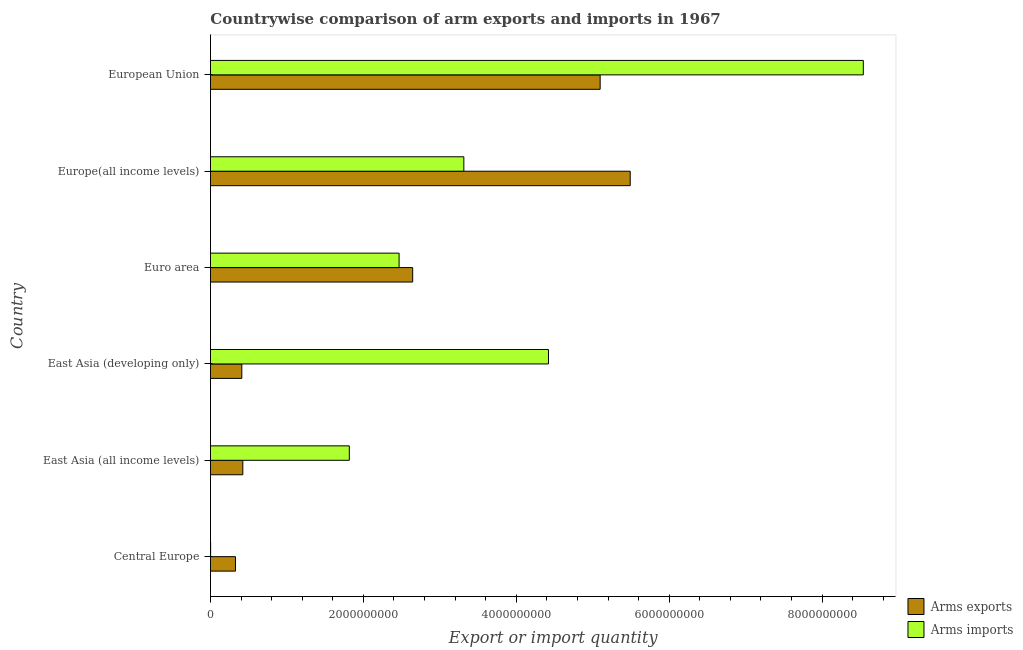How many different coloured bars are there?
Ensure brevity in your answer.  2. Are the number of bars per tick equal to the number of legend labels?
Make the answer very short. Yes. Are the number of bars on each tick of the Y-axis equal?
Keep it short and to the point. Yes. How many bars are there on the 5th tick from the top?
Keep it short and to the point. 2. How many bars are there on the 4th tick from the bottom?
Give a very brief answer. 2. What is the label of the 5th group of bars from the top?
Offer a very short reply. East Asia (all income levels). In how many cases, is the number of bars for a given country not equal to the number of legend labels?
Your response must be concise. 0. What is the arms imports in Europe(all income levels)?
Your response must be concise. 3.31e+09. Across all countries, what is the maximum arms imports?
Provide a short and direct response. 8.54e+09. Across all countries, what is the minimum arms imports?
Give a very brief answer. 2.00e+06. In which country was the arms imports maximum?
Your answer should be very brief. European Union. In which country was the arms imports minimum?
Your answer should be very brief. Central Europe. What is the total arms imports in the graph?
Make the answer very short. 2.06e+1. What is the difference between the arms imports in East Asia (all income levels) and that in Euro area?
Your response must be concise. -6.51e+08. What is the difference between the arms exports in Central Europe and the arms imports in East Asia (developing only)?
Provide a short and direct response. -4.09e+09. What is the average arms exports per country?
Ensure brevity in your answer.  2.40e+09. What is the difference between the arms exports and arms imports in European Union?
Keep it short and to the point. -3.44e+09. In how many countries, is the arms exports greater than 2400000000 ?
Provide a short and direct response. 3. What is the ratio of the arms exports in Euro area to that in European Union?
Ensure brevity in your answer.  0.52. Is the difference between the arms exports in East Asia (all income levels) and European Union greater than the difference between the arms imports in East Asia (all income levels) and European Union?
Offer a terse response. Yes. What is the difference between the highest and the second highest arms imports?
Ensure brevity in your answer.  4.12e+09. What is the difference between the highest and the lowest arms imports?
Your response must be concise. 8.54e+09. What does the 2nd bar from the top in Central Europe represents?
Your response must be concise. Arms exports. What does the 1st bar from the bottom in East Asia (all income levels) represents?
Your answer should be compact. Arms exports. How many bars are there?
Give a very brief answer. 12. What is the difference between two consecutive major ticks on the X-axis?
Offer a very short reply. 2.00e+09. Are the values on the major ticks of X-axis written in scientific E-notation?
Offer a terse response. No. Where does the legend appear in the graph?
Keep it short and to the point. Bottom right. What is the title of the graph?
Your response must be concise. Countrywise comparison of arm exports and imports in 1967. Does "Nonresident" appear as one of the legend labels in the graph?
Offer a terse response. No. What is the label or title of the X-axis?
Provide a short and direct response. Export or import quantity. What is the label or title of the Y-axis?
Offer a very short reply. Country. What is the Export or import quantity of Arms exports in Central Europe?
Your response must be concise. 3.27e+08. What is the Export or import quantity of Arms exports in East Asia (all income levels)?
Your answer should be very brief. 4.23e+08. What is the Export or import quantity of Arms imports in East Asia (all income levels)?
Your response must be concise. 1.82e+09. What is the Export or import quantity in Arms exports in East Asia (developing only)?
Provide a short and direct response. 4.10e+08. What is the Export or import quantity of Arms imports in East Asia (developing only)?
Provide a succinct answer. 4.42e+09. What is the Export or import quantity of Arms exports in Euro area?
Your answer should be compact. 2.64e+09. What is the Export or import quantity in Arms imports in Euro area?
Your answer should be very brief. 2.47e+09. What is the Export or import quantity in Arms exports in Europe(all income levels)?
Give a very brief answer. 5.49e+09. What is the Export or import quantity in Arms imports in Europe(all income levels)?
Make the answer very short. 3.31e+09. What is the Export or import quantity of Arms exports in European Union?
Keep it short and to the point. 5.10e+09. What is the Export or import quantity in Arms imports in European Union?
Give a very brief answer. 8.54e+09. Across all countries, what is the maximum Export or import quantity in Arms exports?
Your answer should be compact. 5.49e+09. Across all countries, what is the maximum Export or import quantity of Arms imports?
Ensure brevity in your answer.  8.54e+09. Across all countries, what is the minimum Export or import quantity of Arms exports?
Provide a short and direct response. 3.27e+08. Across all countries, what is the minimum Export or import quantity in Arms imports?
Provide a short and direct response. 2.00e+06. What is the total Export or import quantity in Arms exports in the graph?
Make the answer very short. 1.44e+1. What is the total Export or import quantity in Arms imports in the graph?
Your response must be concise. 2.06e+1. What is the difference between the Export or import quantity of Arms exports in Central Europe and that in East Asia (all income levels)?
Provide a succinct answer. -9.60e+07. What is the difference between the Export or import quantity of Arms imports in Central Europe and that in East Asia (all income levels)?
Provide a succinct answer. -1.81e+09. What is the difference between the Export or import quantity in Arms exports in Central Europe and that in East Asia (developing only)?
Make the answer very short. -8.30e+07. What is the difference between the Export or import quantity of Arms imports in Central Europe and that in East Asia (developing only)?
Your answer should be very brief. -4.42e+09. What is the difference between the Export or import quantity in Arms exports in Central Europe and that in Euro area?
Your answer should be compact. -2.32e+09. What is the difference between the Export or import quantity of Arms imports in Central Europe and that in Euro area?
Provide a succinct answer. -2.46e+09. What is the difference between the Export or import quantity of Arms exports in Central Europe and that in Europe(all income levels)?
Offer a very short reply. -5.16e+09. What is the difference between the Export or import quantity in Arms imports in Central Europe and that in Europe(all income levels)?
Offer a terse response. -3.31e+09. What is the difference between the Export or import quantity in Arms exports in Central Europe and that in European Union?
Your response must be concise. -4.77e+09. What is the difference between the Export or import quantity in Arms imports in Central Europe and that in European Union?
Make the answer very short. -8.54e+09. What is the difference between the Export or import quantity of Arms exports in East Asia (all income levels) and that in East Asia (developing only)?
Provide a short and direct response. 1.30e+07. What is the difference between the Export or import quantity of Arms imports in East Asia (all income levels) and that in East Asia (developing only)?
Provide a succinct answer. -2.60e+09. What is the difference between the Export or import quantity of Arms exports in East Asia (all income levels) and that in Euro area?
Your answer should be compact. -2.22e+09. What is the difference between the Export or import quantity of Arms imports in East Asia (all income levels) and that in Euro area?
Your answer should be very brief. -6.51e+08. What is the difference between the Export or import quantity in Arms exports in East Asia (all income levels) and that in Europe(all income levels)?
Offer a very short reply. -5.07e+09. What is the difference between the Export or import quantity of Arms imports in East Asia (all income levels) and that in Europe(all income levels)?
Your response must be concise. -1.50e+09. What is the difference between the Export or import quantity in Arms exports in East Asia (all income levels) and that in European Union?
Your response must be concise. -4.67e+09. What is the difference between the Export or import quantity in Arms imports in East Asia (all income levels) and that in European Union?
Offer a very short reply. -6.72e+09. What is the difference between the Export or import quantity of Arms exports in East Asia (developing only) and that in Euro area?
Your answer should be compact. -2.24e+09. What is the difference between the Export or import quantity of Arms imports in East Asia (developing only) and that in Euro area?
Your response must be concise. 1.95e+09. What is the difference between the Export or import quantity of Arms exports in East Asia (developing only) and that in Europe(all income levels)?
Your answer should be compact. -5.08e+09. What is the difference between the Export or import quantity of Arms imports in East Asia (developing only) and that in Europe(all income levels)?
Your answer should be very brief. 1.11e+09. What is the difference between the Export or import quantity of Arms exports in East Asia (developing only) and that in European Union?
Keep it short and to the point. -4.69e+09. What is the difference between the Export or import quantity in Arms imports in East Asia (developing only) and that in European Union?
Keep it short and to the point. -4.12e+09. What is the difference between the Export or import quantity of Arms exports in Euro area and that in Europe(all income levels)?
Ensure brevity in your answer.  -2.84e+09. What is the difference between the Export or import quantity in Arms imports in Euro area and that in Europe(all income levels)?
Give a very brief answer. -8.47e+08. What is the difference between the Export or import quantity of Arms exports in Euro area and that in European Union?
Give a very brief answer. -2.45e+09. What is the difference between the Export or import quantity in Arms imports in Euro area and that in European Union?
Provide a succinct answer. -6.07e+09. What is the difference between the Export or import quantity in Arms exports in Europe(all income levels) and that in European Union?
Your answer should be compact. 3.93e+08. What is the difference between the Export or import quantity of Arms imports in Europe(all income levels) and that in European Union?
Your response must be concise. -5.22e+09. What is the difference between the Export or import quantity in Arms exports in Central Europe and the Export or import quantity in Arms imports in East Asia (all income levels)?
Your answer should be very brief. -1.49e+09. What is the difference between the Export or import quantity of Arms exports in Central Europe and the Export or import quantity of Arms imports in East Asia (developing only)?
Give a very brief answer. -4.09e+09. What is the difference between the Export or import quantity in Arms exports in Central Europe and the Export or import quantity in Arms imports in Euro area?
Offer a very short reply. -2.14e+09. What is the difference between the Export or import quantity of Arms exports in Central Europe and the Export or import quantity of Arms imports in Europe(all income levels)?
Your answer should be very brief. -2.99e+09. What is the difference between the Export or import quantity in Arms exports in Central Europe and the Export or import quantity in Arms imports in European Union?
Ensure brevity in your answer.  -8.21e+09. What is the difference between the Export or import quantity of Arms exports in East Asia (all income levels) and the Export or import quantity of Arms imports in East Asia (developing only)?
Provide a short and direct response. -4.00e+09. What is the difference between the Export or import quantity in Arms exports in East Asia (all income levels) and the Export or import quantity in Arms imports in Euro area?
Your answer should be compact. -2.04e+09. What is the difference between the Export or import quantity of Arms exports in East Asia (all income levels) and the Export or import quantity of Arms imports in Europe(all income levels)?
Provide a short and direct response. -2.89e+09. What is the difference between the Export or import quantity of Arms exports in East Asia (all income levels) and the Export or import quantity of Arms imports in European Union?
Keep it short and to the point. -8.12e+09. What is the difference between the Export or import quantity of Arms exports in East Asia (developing only) and the Export or import quantity of Arms imports in Euro area?
Offer a terse response. -2.06e+09. What is the difference between the Export or import quantity in Arms exports in East Asia (developing only) and the Export or import quantity in Arms imports in Europe(all income levels)?
Your answer should be compact. -2.90e+09. What is the difference between the Export or import quantity of Arms exports in East Asia (developing only) and the Export or import quantity of Arms imports in European Union?
Offer a very short reply. -8.13e+09. What is the difference between the Export or import quantity in Arms exports in Euro area and the Export or import quantity in Arms imports in Europe(all income levels)?
Your response must be concise. -6.69e+08. What is the difference between the Export or import quantity in Arms exports in Euro area and the Export or import quantity in Arms imports in European Union?
Provide a short and direct response. -5.89e+09. What is the difference between the Export or import quantity in Arms exports in Europe(all income levels) and the Export or import quantity in Arms imports in European Union?
Your response must be concise. -3.05e+09. What is the average Export or import quantity of Arms exports per country?
Give a very brief answer. 2.40e+09. What is the average Export or import quantity of Arms imports per country?
Ensure brevity in your answer.  3.43e+09. What is the difference between the Export or import quantity in Arms exports and Export or import quantity in Arms imports in Central Europe?
Offer a terse response. 3.25e+08. What is the difference between the Export or import quantity of Arms exports and Export or import quantity of Arms imports in East Asia (all income levels)?
Offer a very short reply. -1.39e+09. What is the difference between the Export or import quantity in Arms exports and Export or import quantity in Arms imports in East Asia (developing only)?
Your answer should be compact. -4.01e+09. What is the difference between the Export or import quantity in Arms exports and Export or import quantity in Arms imports in Euro area?
Ensure brevity in your answer.  1.78e+08. What is the difference between the Export or import quantity of Arms exports and Export or import quantity of Arms imports in Europe(all income levels)?
Offer a terse response. 2.18e+09. What is the difference between the Export or import quantity of Arms exports and Export or import quantity of Arms imports in European Union?
Provide a short and direct response. -3.44e+09. What is the ratio of the Export or import quantity of Arms exports in Central Europe to that in East Asia (all income levels)?
Ensure brevity in your answer.  0.77. What is the ratio of the Export or import quantity in Arms imports in Central Europe to that in East Asia (all income levels)?
Offer a terse response. 0. What is the ratio of the Export or import quantity of Arms exports in Central Europe to that in East Asia (developing only)?
Give a very brief answer. 0.8. What is the ratio of the Export or import quantity of Arms imports in Central Europe to that in East Asia (developing only)?
Provide a succinct answer. 0. What is the ratio of the Export or import quantity in Arms exports in Central Europe to that in Euro area?
Ensure brevity in your answer.  0.12. What is the ratio of the Export or import quantity of Arms imports in Central Europe to that in Euro area?
Your answer should be compact. 0. What is the ratio of the Export or import quantity in Arms exports in Central Europe to that in Europe(all income levels)?
Provide a short and direct response. 0.06. What is the ratio of the Export or import quantity of Arms imports in Central Europe to that in Europe(all income levels)?
Provide a succinct answer. 0. What is the ratio of the Export or import quantity in Arms exports in Central Europe to that in European Union?
Your response must be concise. 0.06. What is the ratio of the Export or import quantity of Arms exports in East Asia (all income levels) to that in East Asia (developing only)?
Provide a short and direct response. 1.03. What is the ratio of the Export or import quantity in Arms imports in East Asia (all income levels) to that in East Asia (developing only)?
Provide a succinct answer. 0.41. What is the ratio of the Export or import quantity in Arms exports in East Asia (all income levels) to that in Euro area?
Your answer should be compact. 0.16. What is the ratio of the Export or import quantity of Arms imports in East Asia (all income levels) to that in Euro area?
Offer a very short reply. 0.74. What is the ratio of the Export or import quantity of Arms exports in East Asia (all income levels) to that in Europe(all income levels)?
Make the answer very short. 0.08. What is the ratio of the Export or import quantity in Arms imports in East Asia (all income levels) to that in Europe(all income levels)?
Keep it short and to the point. 0.55. What is the ratio of the Export or import quantity of Arms exports in East Asia (all income levels) to that in European Union?
Provide a succinct answer. 0.08. What is the ratio of the Export or import quantity in Arms imports in East Asia (all income levels) to that in European Union?
Offer a terse response. 0.21. What is the ratio of the Export or import quantity in Arms exports in East Asia (developing only) to that in Euro area?
Make the answer very short. 0.15. What is the ratio of the Export or import quantity in Arms imports in East Asia (developing only) to that in Euro area?
Offer a terse response. 1.79. What is the ratio of the Export or import quantity in Arms exports in East Asia (developing only) to that in Europe(all income levels)?
Offer a very short reply. 0.07. What is the ratio of the Export or import quantity of Arms imports in East Asia (developing only) to that in Europe(all income levels)?
Ensure brevity in your answer.  1.33. What is the ratio of the Export or import quantity in Arms exports in East Asia (developing only) to that in European Union?
Your answer should be compact. 0.08. What is the ratio of the Export or import quantity of Arms imports in East Asia (developing only) to that in European Union?
Provide a short and direct response. 0.52. What is the ratio of the Export or import quantity in Arms exports in Euro area to that in Europe(all income levels)?
Keep it short and to the point. 0.48. What is the ratio of the Export or import quantity of Arms imports in Euro area to that in Europe(all income levels)?
Make the answer very short. 0.74. What is the ratio of the Export or import quantity in Arms exports in Euro area to that in European Union?
Ensure brevity in your answer.  0.52. What is the ratio of the Export or import quantity of Arms imports in Euro area to that in European Union?
Offer a very short reply. 0.29. What is the ratio of the Export or import quantity in Arms exports in Europe(all income levels) to that in European Union?
Provide a short and direct response. 1.08. What is the ratio of the Export or import quantity in Arms imports in Europe(all income levels) to that in European Union?
Offer a terse response. 0.39. What is the difference between the highest and the second highest Export or import quantity of Arms exports?
Offer a very short reply. 3.93e+08. What is the difference between the highest and the second highest Export or import quantity of Arms imports?
Offer a terse response. 4.12e+09. What is the difference between the highest and the lowest Export or import quantity of Arms exports?
Give a very brief answer. 5.16e+09. What is the difference between the highest and the lowest Export or import quantity of Arms imports?
Make the answer very short. 8.54e+09. 